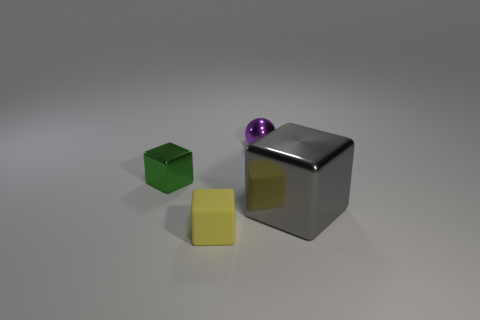Subtract all shiny blocks. How many blocks are left? 1 Add 2 green metallic blocks. How many objects exist? 6 Subtract all cubes. How many objects are left? 1 Subtract all tiny metallic things. Subtract all big metal blocks. How many objects are left? 1 Add 1 purple balls. How many purple balls are left? 2 Add 2 tiny brown matte cylinders. How many tiny brown matte cylinders exist? 2 Subtract 0 red cylinders. How many objects are left? 4 